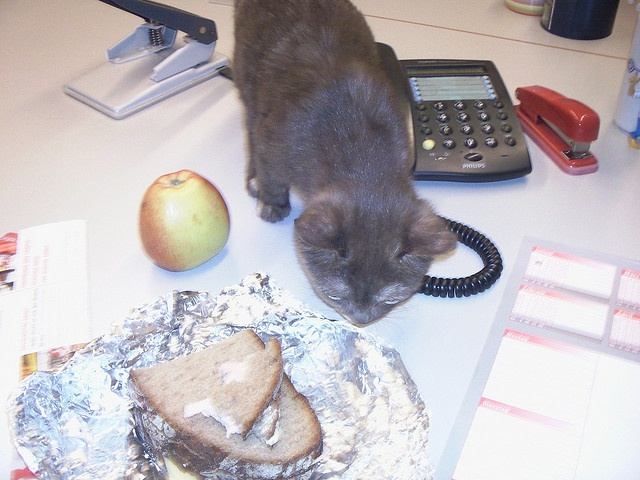Describe the objects in this image and their specific colors. I can see cat in darkgray, gray, and black tones, sandwich in darkgray, lightgray, and gray tones, and apple in darkgray, khaki, beige, and tan tones in this image. 